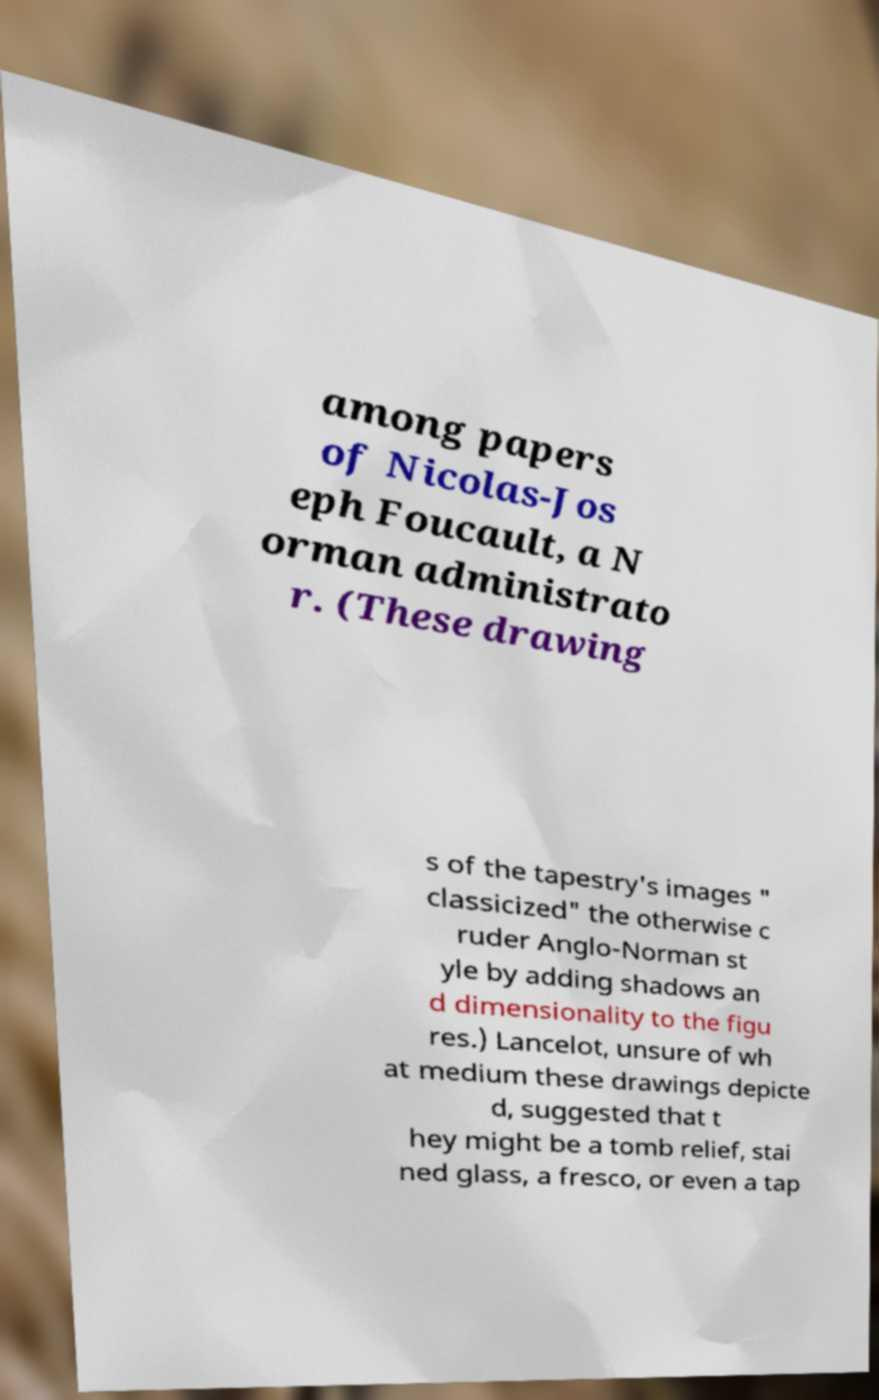I need the written content from this picture converted into text. Can you do that? among papers of Nicolas-Jos eph Foucault, a N orman administrato r. (These drawing s of the tapestry's images " classicized" the otherwise c ruder Anglo-Norman st yle by adding shadows an d dimensionality to the figu res.) Lancelot, unsure of wh at medium these drawings depicte d, suggested that t hey might be a tomb relief, stai ned glass, a fresco, or even a tap 